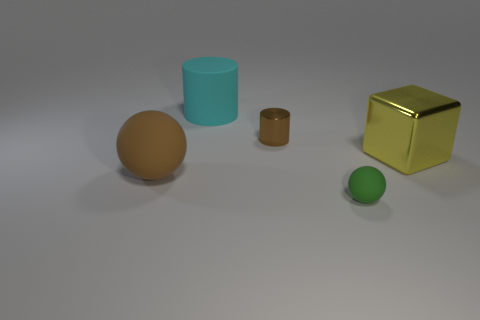Add 1 small purple rubber cylinders. How many objects exist? 6 Subtract all spheres. How many objects are left? 3 Subtract 1 brown balls. How many objects are left? 4 Subtract all big cyan matte objects. Subtract all cyan cubes. How many objects are left? 4 Add 2 cyan cylinders. How many cyan cylinders are left? 3 Add 2 matte things. How many matte things exist? 5 